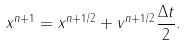Convert formula to latex. <formula><loc_0><loc_0><loc_500><loc_500>x ^ { n + 1 } = x ^ { n + 1 / 2 } + v ^ { n + 1 / 2 } \frac { \Delta t } { 2 } .</formula> 